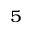Convert formula to latex. <formula><loc_0><loc_0><loc_500><loc_500>^ { 5 }</formula> 